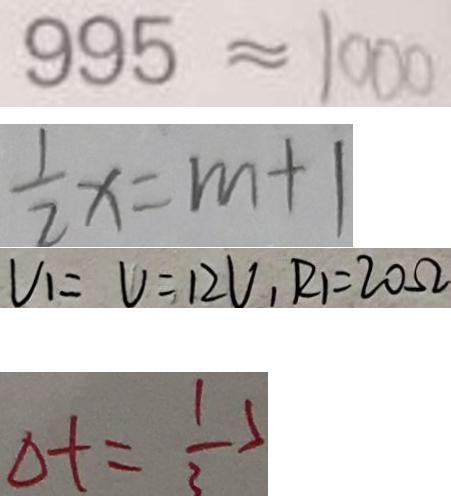Convert formula to latex. <formula><loc_0><loc_0><loc_500><loc_500>9 9 5 \approx 1 0 0 0 
 \frac { 1 } { 2 } x = m + 1 
 V _ { 1 } = V = 1 2 V _ { 1 } R _ { 1 } = 2 0 \Omega 
 \Delta t = \frac { 1 } { 3 }</formula> 